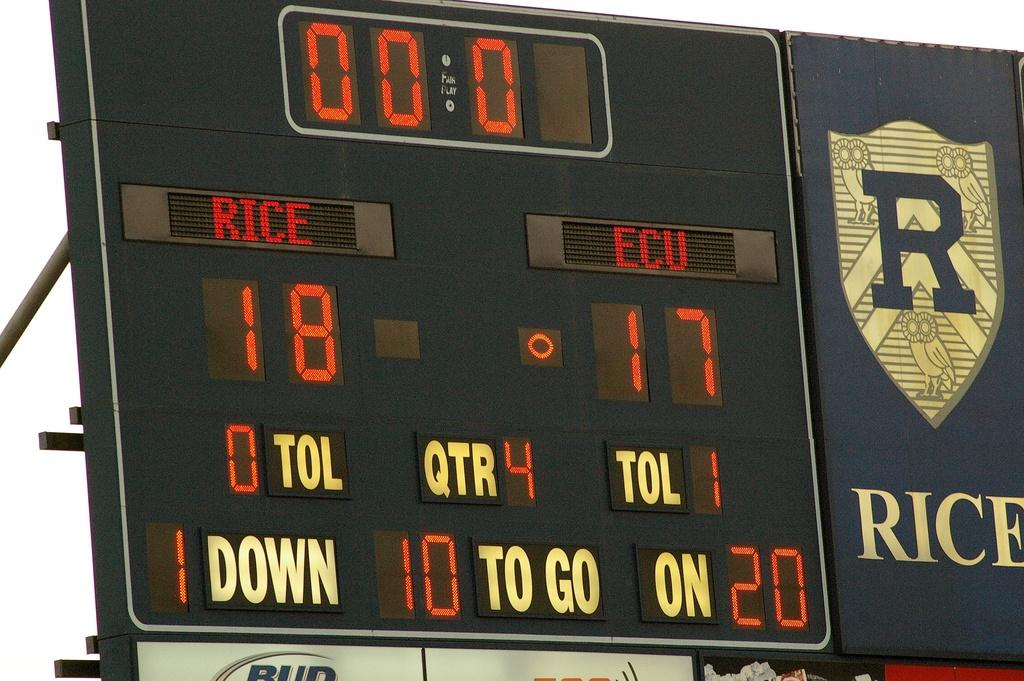<image>
Summarize the visual content of the image. The word "RICE" is displayed on the scoreboard. 